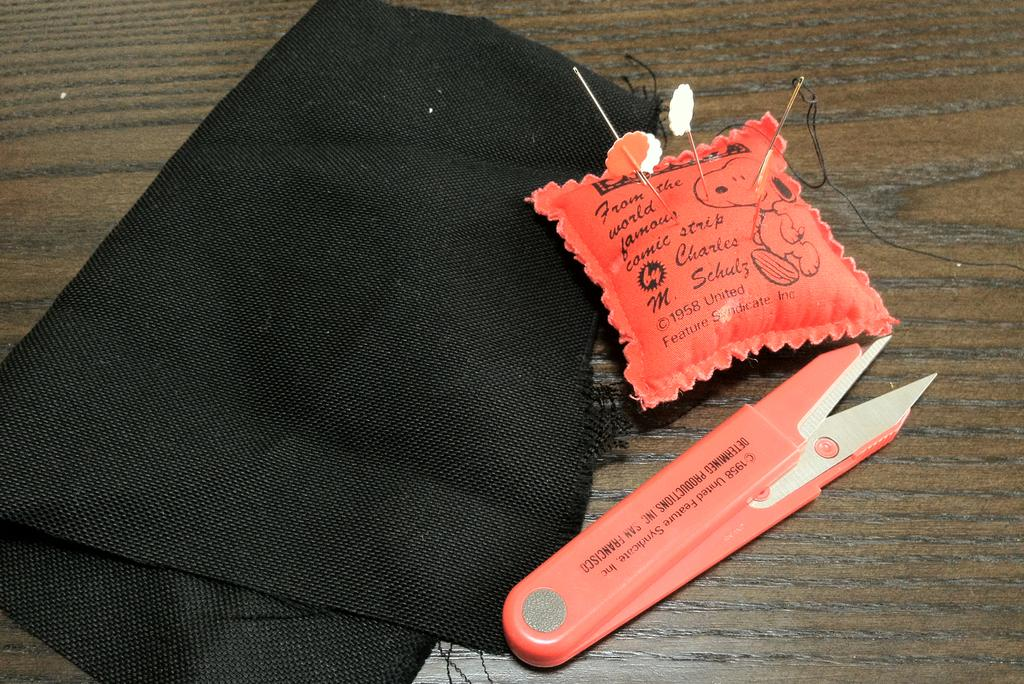What type of material is present in the image? There is black cloth in the image. What object with needles can be seen in the image? There is a sponge item with needles in the image. Where is the knife located in the image? The knife is on a wooden surface in the image. What color is the paint on the watch in the image? There is no watch or paint present in the image. Can you describe the kitten playing with the sponge item in the image? There is no kitten present in the image; it only features black cloth, a sponge item with needles, and a knife on a wooden surface. 